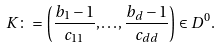<formula> <loc_0><loc_0><loc_500><loc_500>K \colon = \left ( \frac { b _ { 1 } - 1 } { c _ { 1 1 } } , \mathellipsis , \frac { b _ { d } - 1 } { c _ { d d } } \right ) \in D ^ { 0 } .</formula> 